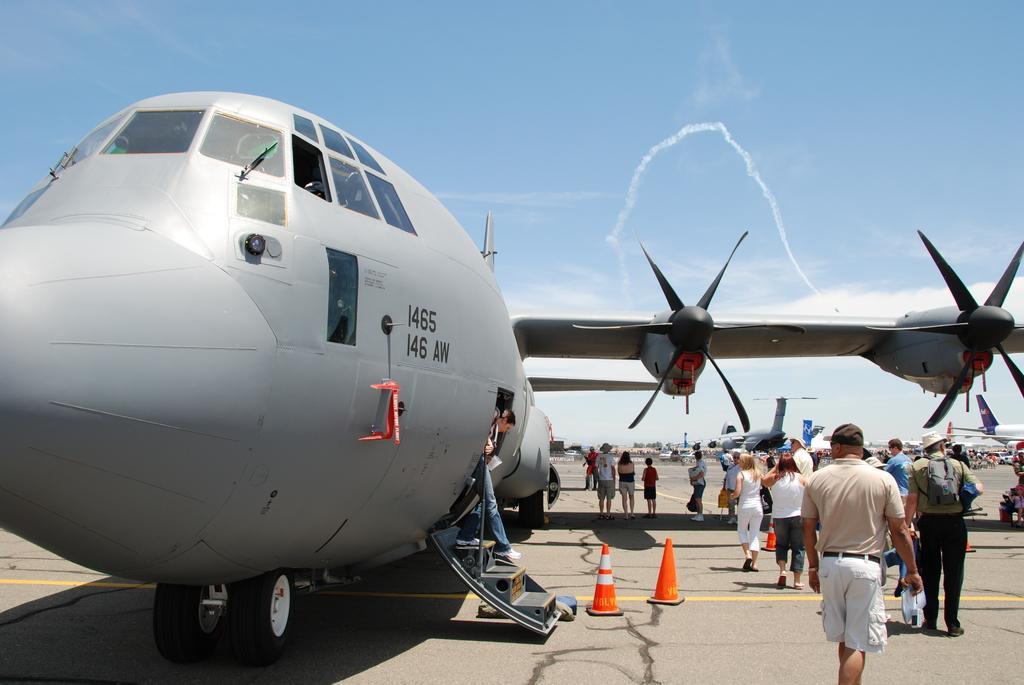Can you describe this image briefly? In this image I can see an airplane in the front and on the right side of it I can see number of people are standing. I can also see few orange colour cones on the right side. In the background I can see few more airplanes, clouds and the sky. 